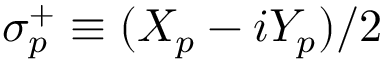<formula> <loc_0><loc_0><loc_500><loc_500>\sigma _ { p } ^ { + } \equiv ( { X } _ { p } - i { Y } _ { p } ) / 2</formula> 